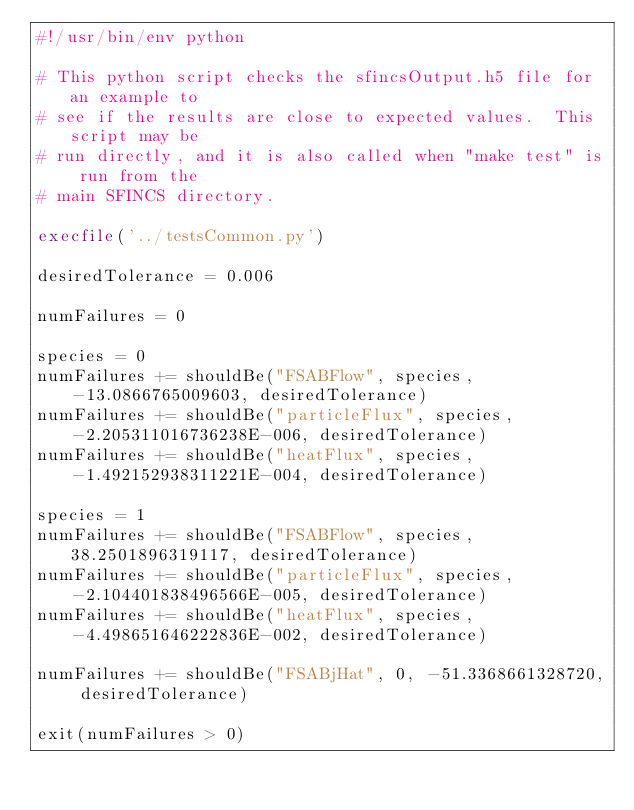<code> <loc_0><loc_0><loc_500><loc_500><_Python_>#!/usr/bin/env python

# This python script checks the sfincsOutput.h5 file for an example to 
# see if the results are close to expected values.  This script may be
# run directly, and it is also called when "make test" is run from the
# main SFINCS directory.

execfile('../testsCommon.py')

desiredTolerance = 0.006

numFailures = 0

species = 0
numFailures += shouldBe("FSABFlow", species, -13.0866765009603, desiredTolerance)
numFailures += shouldBe("particleFlux", species, -2.205311016736238E-006, desiredTolerance)
numFailures += shouldBe("heatFlux", species, -1.492152938311221E-004, desiredTolerance)

species = 1
numFailures += shouldBe("FSABFlow", species, 38.2501896319117, desiredTolerance)
numFailures += shouldBe("particleFlux", species, -2.104401838496566E-005, desiredTolerance)
numFailures += shouldBe("heatFlux", species, -4.498651646222836E-002, desiredTolerance)

numFailures += shouldBe("FSABjHat", 0, -51.3368661328720, desiredTolerance)

exit(numFailures > 0)
</code> 